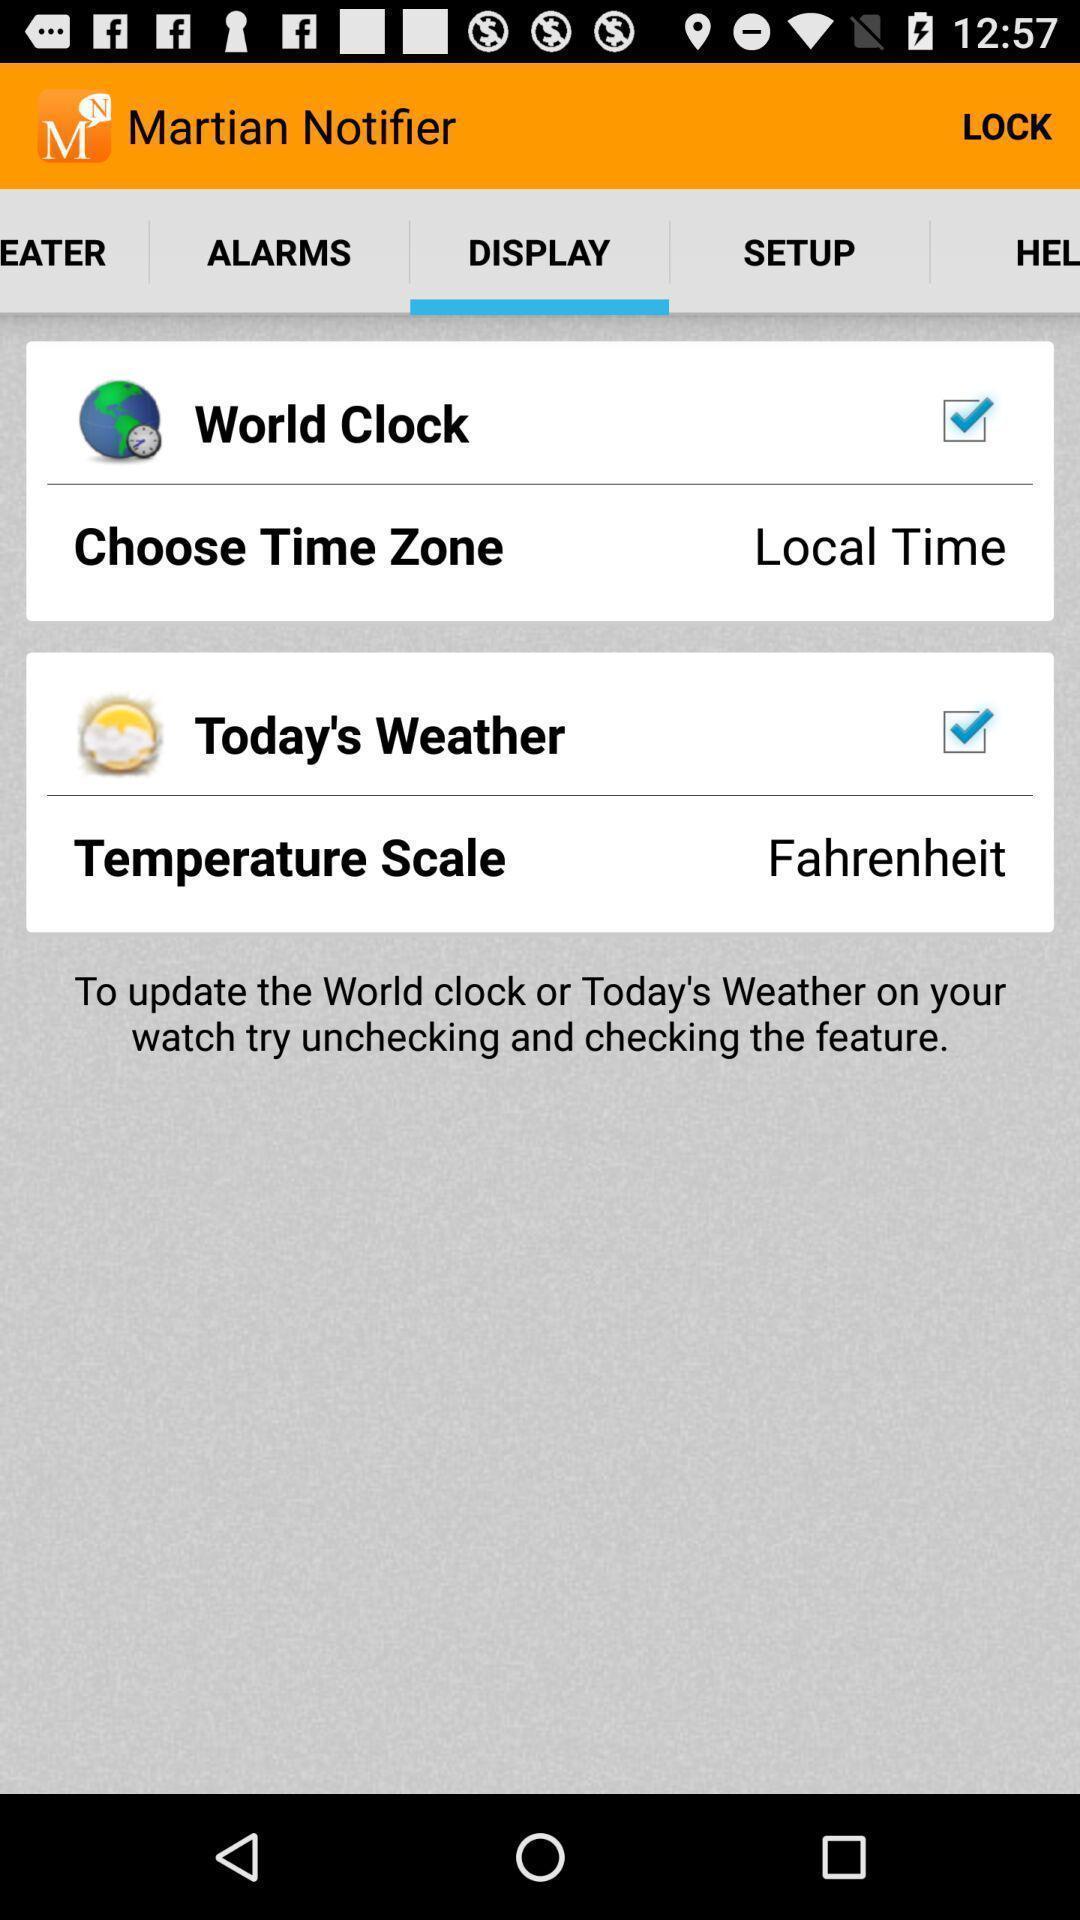Please provide a description for this image. Page displaying to select the clock and weather in app. 